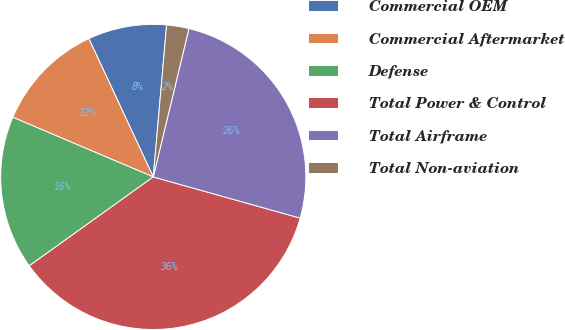<chart> <loc_0><loc_0><loc_500><loc_500><pie_chart><fcel>Commercial OEM<fcel>Commercial Aftermarket<fcel>Defense<fcel>Total Power & Control<fcel>Total Airframe<fcel>Total Non-aviation<nl><fcel>8.33%<fcel>11.67%<fcel>16.29%<fcel>35.75%<fcel>25.59%<fcel>2.36%<nl></chart> 